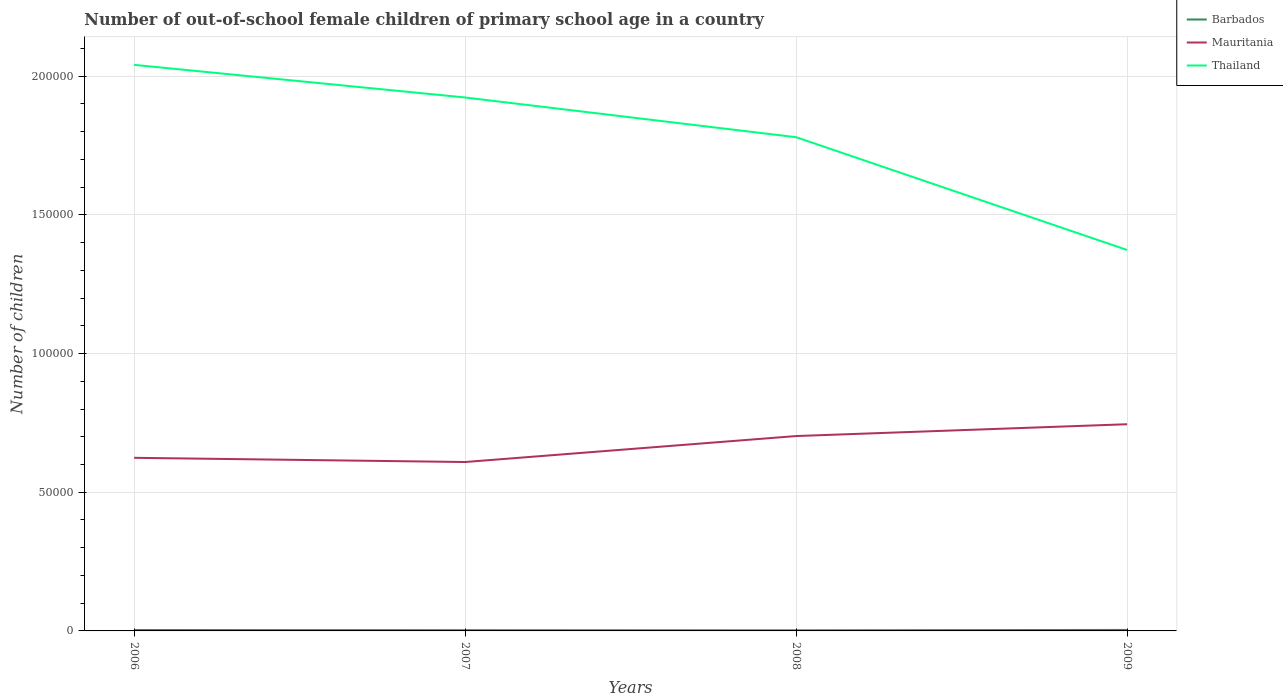Is the number of lines equal to the number of legend labels?
Your response must be concise. Yes. Across all years, what is the maximum number of out-of-school female children in Thailand?
Your response must be concise. 1.37e+05. In which year was the number of out-of-school female children in Mauritania maximum?
Offer a terse response. 2007. What is the total number of out-of-school female children in Barbados in the graph?
Offer a very short reply. 108. What is the difference between the highest and the second highest number of out-of-school female children in Barbados?
Your answer should be very brief. 142. What is the difference between the highest and the lowest number of out-of-school female children in Thailand?
Give a very brief answer. 3. Is the number of out-of-school female children in Mauritania strictly greater than the number of out-of-school female children in Thailand over the years?
Your answer should be compact. Yes. What is the difference between two consecutive major ticks on the Y-axis?
Offer a very short reply. 5.00e+04. Are the values on the major ticks of Y-axis written in scientific E-notation?
Keep it short and to the point. No. Does the graph contain grids?
Make the answer very short. Yes. How are the legend labels stacked?
Offer a very short reply. Vertical. What is the title of the graph?
Ensure brevity in your answer.  Number of out-of-school female children of primary school age in a country. What is the label or title of the X-axis?
Ensure brevity in your answer.  Years. What is the label or title of the Y-axis?
Offer a very short reply. Number of children. What is the Number of children in Barbados in 2006?
Provide a succinct answer. 327. What is the Number of children in Mauritania in 2006?
Offer a very short reply. 6.24e+04. What is the Number of children of Thailand in 2006?
Your answer should be compact. 2.04e+05. What is the Number of children in Barbados in 2007?
Give a very brief answer. 263. What is the Number of children in Mauritania in 2007?
Keep it short and to the point. 6.09e+04. What is the Number of children in Thailand in 2007?
Your answer should be very brief. 1.92e+05. What is the Number of children in Barbados in 2008?
Give a very brief answer. 219. What is the Number of children of Mauritania in 2008?
Your answer should be very brief. 7.02e+04. What is the Number of children of Thailand in 2008?
Keep it short and to the point. 1.78e+05. What is the Number of children of Barbados in 2009?
Your answer should be very brief. 361. What is the Number of children in Mauritania in 2009?
Offer a very short reply. 7.45e+04. What is the Number of children in Thailand in 2009?
Provide a short and direct response. 1.37e+05. Across all years, what is the maximum Number of children of Barbados?
Your answer should be very brief. 361. Across all years, what is the maximum Number of children in Mauritania?
Offer a very short reply. 7.45e+04. Across all years, what is the maximum Number of children in Thailand?
Offer a terse response. 2.04e+05. Across all years, what is the minimum Number of children in Barbados?
Your answer should be compact. 219. Across all years, what is the minimum Number of children in Mauritania?
Your response must be concise. 6.09e+04. Across all years, what is the minimum Number of children of Thailand?
Make the answer very short. 1.37e+05. What is the total Number of children of Barbados in the graph?
Offer a very short reply. 1170. What is the total Number of children of Mauritania in the graph?
Provide a short and direct response. 2.68e+05. What is the total Number of children in Thailand in the graph?
Offer a very short reply. 7.12e+05. What is the difference between the Number of children of Barbados in 2006 and that in 2007?
Provide a succinct answer. 64. What is the difference between the Number of children of Mauritania in 2006 and that in 2007?
Your response must be concise. 1511. What is the difference between the Number of children of Thailand in 2006 and that in 2007?
Keep it short and to the point. 1.18e+04. What is the difference between the Number of children of Barbados in 2006 and that in 2008?
Offer a very short reply. 108. What is the difference between the Number of children of Mauritania in 2006 and that in 2008?
Ensure brevity in your answer.  -7847. What is the difference between the Number of children of Thailand in 2006 and that in 2008?
Offer a very short reply. 2.61e+04. What is the difference between the Number of children in Barbados in 2006 and that in 2009?
Keep it short and to the point. -34. What is the difference between the Number of children of Mauritania in 2006 and that in 2009?
Provide a short and direct response. -1.21e+04. What is the difference between the Number of children of Thailand in 2006 and that in 2009?
Provide a short and direct response. 6.67e+04. What is the difference between the Number of children in Barbados in 2007 and that in 2008?
Your answer should be compact. 44. What is the difference between the Number of children in Mauritania in 2007 and that in 2008?
Provide a succinct answer. -9358. What is the difference between the Number of children of Thailand in 2007 and that in 2008?
Make the answer very short. 1.43e+04. What is the difference between the Number of children of Barbados in 2007 and that in 2009?
Your response must be concise. -98. What is the difference between the Number of children in Mauritania in 2007 and that in 2009?
Keep it short and to the point. -1.36e+04. What is the difference between the Number of children of Thailand in 2007 and that in 2009?
Provide a short and direct response. 5.50e+04. What is the difference between the Number of children in Barbados in 2008 and that in 2009?
Make the answer very short. -142. What is the difference between the Number of children of Mauritania in 2008 and that in 2009?
Provide a succinct answer. -4258. What is the difference between the Number of children in Thailand in 2008 and that in 2009?
Make the answer very short. 4.07e+04. What is the difference between the Number of children in Barbados in 2006 and the Number of children in Mauritania in 2007?
Your answer should be very brief. -6.06e+04. What is the difference between the Number of children in Barbados in 2006 and the Number of children in Thailand in 2007?
Offer a very short reply. -1.92e+05. What is the difference between the Number of children of Mauritania in 2006 and the Number of children of Thailand in 2007?
Offer a terse response. -1.30e+05. What is the difference between the Number of children in Barbados in 2006 and the Number of children in Mauritania in 2008?
Keep it short and to the point. -6.99e+04. What is the difference between the Number of children of Barbados in 2006 and the Number of children of Thailand in 2008?
Your answer should be very brief. -1.78e+05. What is the difference between the Number of children in Mauritania in 2006 and the Number of children in Thailand in 2008?
Give a very brief answer. -1.16e+05. What is the difference between the Number of children in Barbados in 2006 and the Number of children in Mauritania in 2009?
Give a very brief answer. -7.42e+04. What is the difference between the Number of children of Barbados in 2006 and the Number of children of Thailand in 2009?
Offer a terse response. -1.37e+05. What is the difference between the Number of children of Mauritania in 2006 and the Number of children of Thailand in 2009?
Offer a terse response. -7.49e+04. What is the difference between the Number of children of Barbados in 2007 and the Number of children of Mauritania in 2008?
Provide a short and direct response. -7.00e+04. What is the difference between the Number of children of Barbados in 2007 and the Number of children of Thailand in 2008?
Give a very brief answer. -1.78e+05. What is the difference between the Number of children of Mauritania in 2007 and the Number of children of Thailand in 2008?
Offer a terse response. -1.17e+05. What is the difference between the Number of children of Barbados in 2007 and the Number of children of Mauritania in 2009?
Provide a succinct answer. -7.42e+04. What is the difference between the Number of children in Barbados in 2007 and the Number of children in Thailand in 2009?
Keep it short and to the point. -1.37e+05. What is the difference between the Number of children in Mauritania in 2007 and the Number of children in Thailand in 2009?
Give a very brief answer. -7.64e+04. What is the difference between the Number of children of Barbados in 2008 and the Number of children of Mauritania in 2009?
Your answer should be very brief. -7.43e+04. What is the difference between the Number of children in Barbados in 2008 and the Number of children in Thailand in 2009?
Give a very brief answer. -1.37e+05. What is the difference between the Number of children in Mauritania in 2008 and the Number of children in Thailand in 2009?
Offer a very short reply. -6.71e+04. What is the average Number of children of Barbados per year?
Provide a short and direct response. 292.5. What is the average Number of children in Mauritania per year?
Provide a short and direct response. 6.70e+04. What is the average Number of children of Thailand per year?
Provide a succinct answer. 1.78e+05. In the year 2006, what is the difference between the Number of children of Barbados and Number of children of Mauritania?
Your answer should be very brief. -6.21e+04. In the year 2006, what is the difference between the Number of children in Barbados and Number of children in Thailand?
Give a very brief answer. -2.04e+05. In the year 2006, what is the difference between the Number of children in Mauritania and Number of children in Thailand?
Give a very brief answer. -1.42e+05. In the year 2007, what is the difference between the Number of children of Barbados and Number of children of Mauritania?
Offer a very short reply. -6.06e+04. In the year 2007, what is the difference between the Number of children of Barbados and Number of children of Thailand?
Offer a very short reply. -1.92e+05. In the year 2007, what is the difference between the Number of children of Mauritania and Number of children of Thailand?
Give a very brief answer. -1.31e+05. In the year 2008, what is the difference between the Number of children in Barbados and Number of children in Mauritania?
Give a very brief answer. -7.00e+04. In the year 2008, what is the difference between the Number of children of Barbados and Number of children of Thailand?
Your answer should be compact. -1.78e+05. In the year 2008, what is the difference between the Number of children of Mauritania and Number of children of Thailand?
Your response must be concise. -1.08e+05. In the year 2009, what is the difference between the Number of children in Barbados and Number of children in Mauritania?
Keep it short and to the point. -7.41e+04. In the year 2009, what is the difference between the Number of children of Barbados and Number of children of Thailand?
Provide a succinct answer. -1.37e+05. In the year 2009, what is the difference between the Number of children of Mauritania and Number of children of Thailand?
Your answer should be compact. -6.28e+04. What is the ratio of the Number of children of Barbados in 2006 to that in 2007?
Give a very brief answer. 1.24. What is the ratio of the Number of children in Mauritania in 2006 to that in 2007?
Ensure brevity in your answer.  1.02. What is the ratio of the Number of children of Thailand in 2006 to that in 2007?
Your answer should be compact. 1.06. What is the ratio of the Number of children in Barbados in 2006 to that in 2008?
Provide a succinct answer. 1.49. What is the ratio of the Number of children of Mauritania in 2006 to that in 2008?
Your answer should be very brief. 0.89. What is the ratio of the Number of children in Thailand in 2006 to that in 2008?
Keep it short and to the point. 1.15. What is the ratio of the Number of children of Barbados in 2006 to that in 2009?
Give a very brief answer. 0.91. What is the ratio of the Number of children of Mauritania in 2006 to that in 2009?
Provide a succinct answer. 0.84. What is the ratio of the Number of children of Thailand in 2006 to that in 2009?
Offer a very short reply. 1.49. What is the ratio of the Number of children of Barbados in 2007 to that in 2008?
Your answer should be compact. 1.2. What is the ratio of the Number of children of Mauritania in 2007 to that in 2008?
Provide a succinct answer. 0.87. What is the ratio of the Number of children of Thailand in 2007 to that in 2008?
Give a very brief answer. 1.08. What is the ratio of the Number of children in Barbados in 2007 to that in 2009?
Your response must be concise. 0.73. What is the ratio of the Number of children of Mauritania in 2007 to that in 2009?
Make the answer very short. 0.82. What is the ratio of the Number of children in Thailand in 2007 to that in 2009?
Give a very brief answer. 1.4. What is the ratio of the Number of children of Barbados in 2008 to that in 2009?
Make the answer very short. 0.61. What is the ratio of the Number of children of Mauritania in 2008 to that in 2009?
Keep it short and to the point. 0.94. What is the ratio of the Number of children of Thailand in 2008 to that in 2009?
Make the answer very short. 1.3. What is the difference between the highest and the second highest Number of children in Mauritania?
Offer a terse response. 4258. What is the difference between the highest and the second highest Number of children of Thailand?
Your response must be concise. 1.18e+04. What is the difference between the highest and the lowest Number of children in Barbados?
Provide a succinct answer. 142. What is the difference between the highest and the lowest Number of children of Mauritania?
Your response must be concise. 1.36e+04. What is the difference between the highest and the lowest Number of children in Thailand?
Offer a terse response. 6.67e+04. 